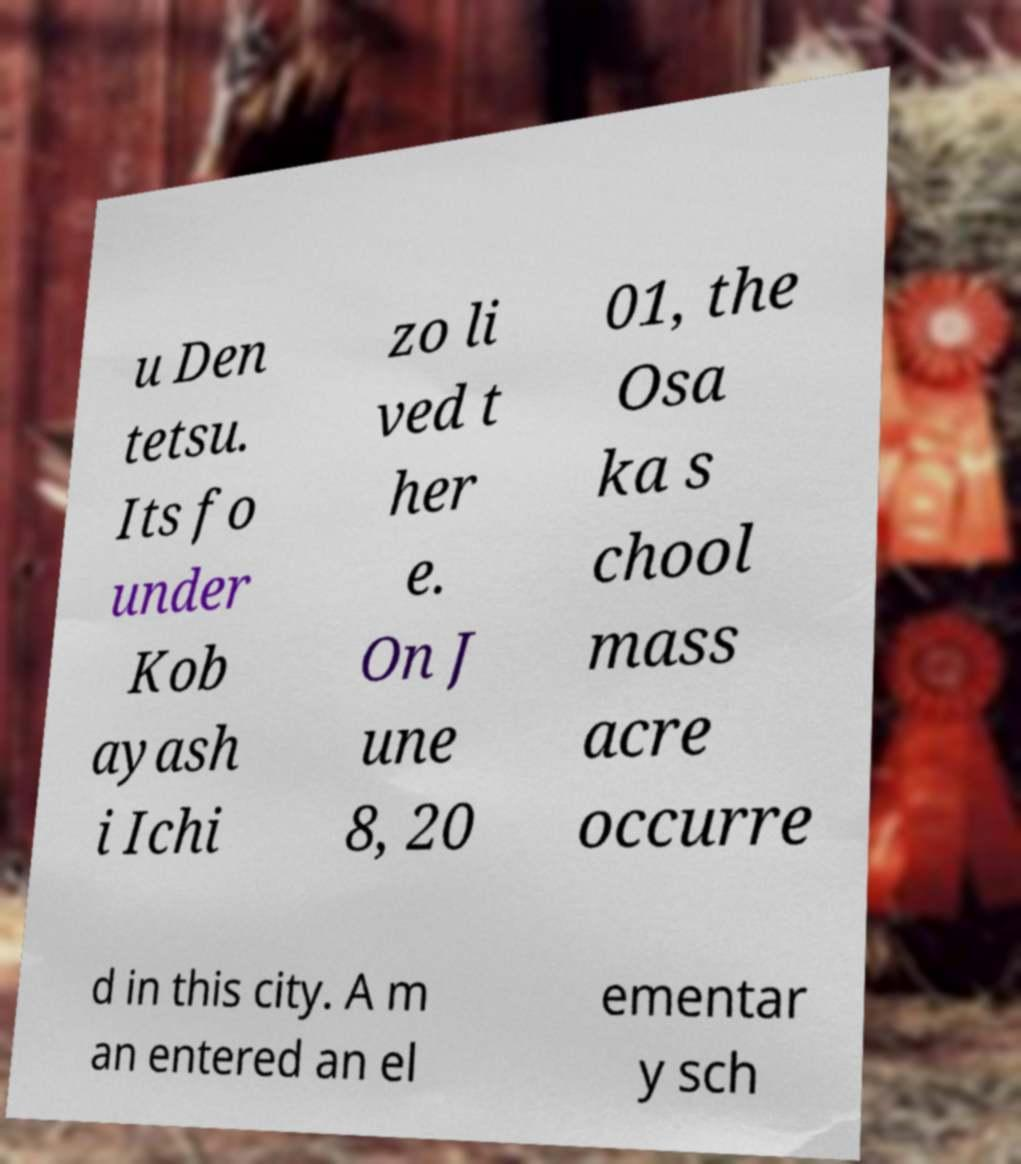Could you extract and type out the text from this image? u Den tetsu. Its fo under Kob ayash i Ichi zo li ved t her e. On J une 8, 20 01, the Osa ka s chool mass acre occurre d in this city. A m an entered an el ementar y sch 